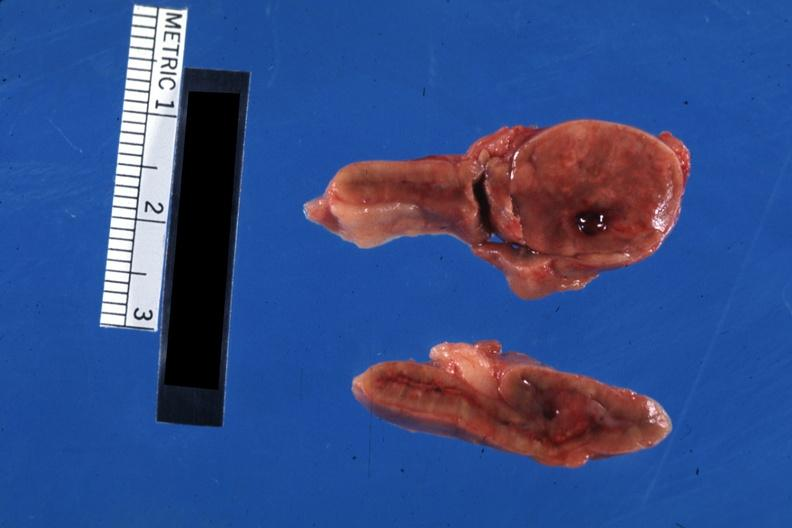s nipple duplication present?
Answer the question using a single word or phrase. No 